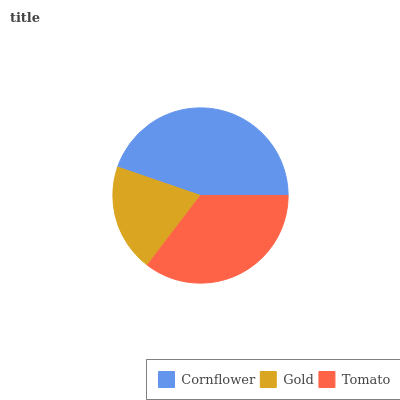Is Gold the minimum?
Answer yes or no. Yes. Is Cornflower the maximum?
Answer yes or no. Yes. Is Tomato the minimum?
Answer yes or no. No. Is Tomato the maximum?
Answer yes or no. No. Is Tomato greater than Gold?
Answer yes or no. Yes. Is Gold less than Tomato?
Answer yes or no. Yes. Is Gold greater than Tomato?
Answer yes or no. No. Is Tomato less than Gold?
Answer yes or no. No. Is Tomato the high median?
Answer yes or no. Yes. Is Tomato the low median?
Answer yes or no. Yes. Is Gold the high median?
Answer yes or no. No. Is Gold the low median?
Answer yes or no. No. 